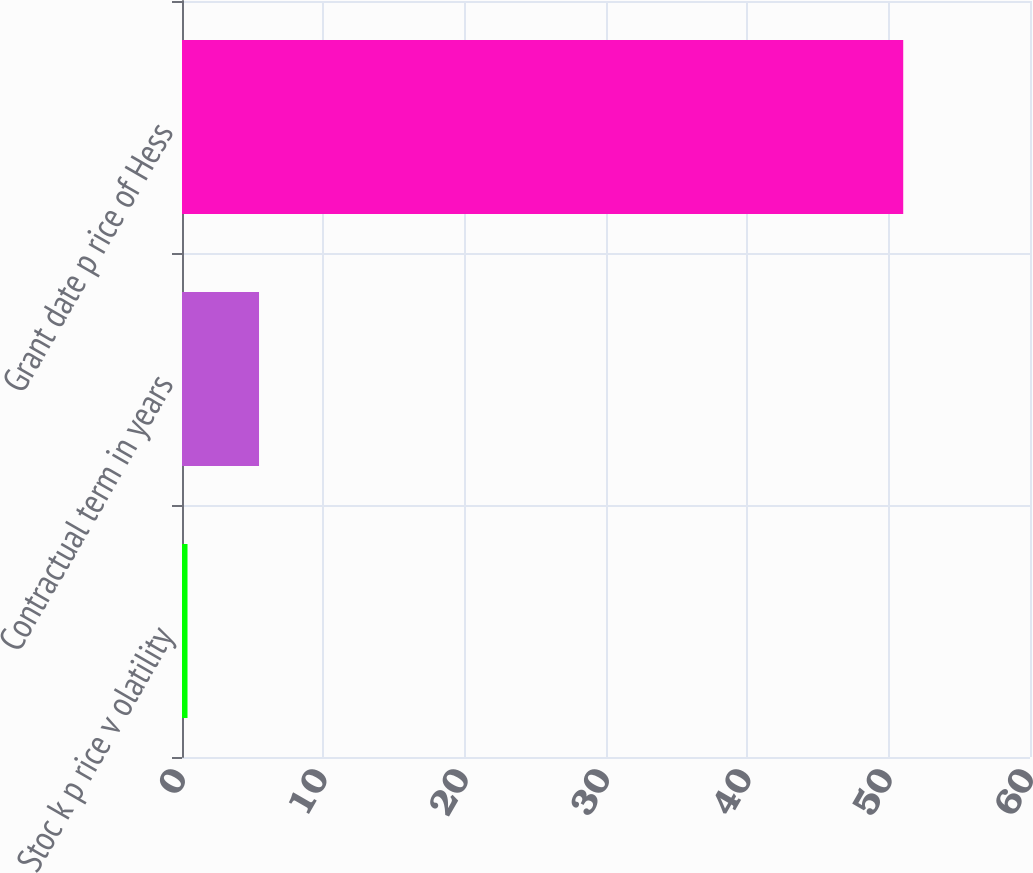Convert chart. <chart><loc_0><loc_0><loc_500><loc_500><bar_chart><fcel>Stoc k p rice v olatility<fcel>Contractual term in years<fcel>Grant date p rice of Hess<nl><fcel>0.39<fcel>5.45<fcel>51.03<nl></chart> 